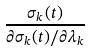Convert formula to latex. <formula><loc_0><loc_0><loc_500><loc_500>\frac { \sigma _ { k } ( t ) } { \partial \sigma _ { k } ( t ) / \partial \lambda _ { k } }</formula> 